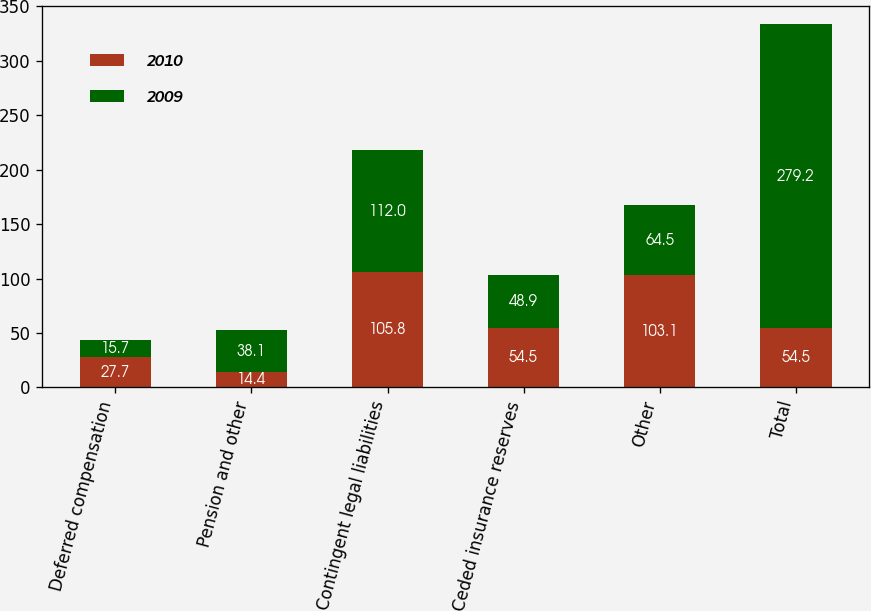Convert chart. <chart><loc_0><loc_0><loc_500><loc_500><stacked_bar_chart><ecel><fcel>Deferred compensation<fcel>Pension and other<fcel>Contingent legal liabilities<fcel>Ceded insurance reserves<fcel>Other<fcel>Total<nl><fcel>2010<fcel>27.7<fcel>14.4<fcel>105.8<fcel>54.5<fcel>103.1<fcel>54.5<nl><fcel>2009<fcel>15.7<fcel>38.1<fcel>112<fcel>48.9<fcel>64.5<fcel>279.2<nl></chart> 